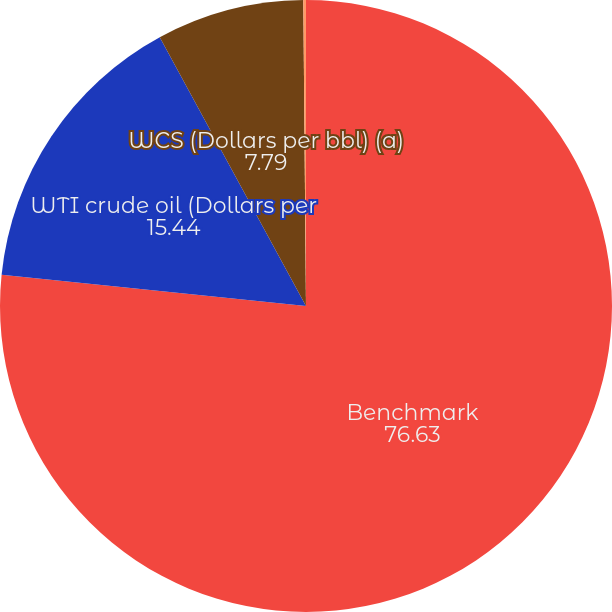Convert chart. <chart><loc_0><loc_0><loc_500><loc_500><pie_chart><fcel>Benchmark<fcel>WTI crude oil (Dollars per<fcel>WCS (Dollars per bbl) (a)<fcel>AECO natural gas sales index<nl><fcel>76.63%<fcel>15.44%<fcel>7.79%<fcel>0.14%<nl></chart> 